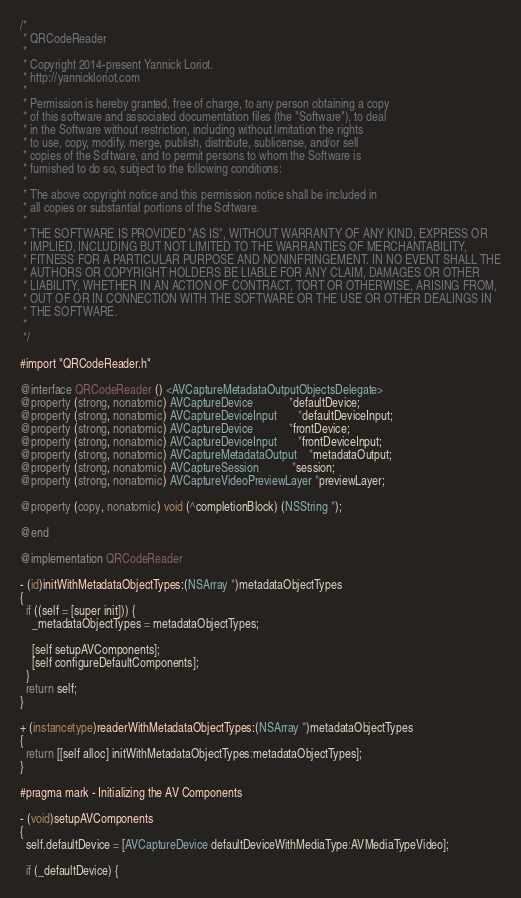<code> <loc_0><loc_0><loc_500><loc_500><_ObjectiveC_>/*
 * QRCodeReader
 *
 * Copyright 2014-present Yannick Loriot.
 * http://yannickloriot.com
 *
 * Permission is hereby granted, free of charge, to any person obtaining a copy
 * of this software and associated documentation files (the "Software"), to deal
 * in the Software without restriction, including without limitation the rights
 * to use, copy, modify, merge, publish, distribute, sublicense, and/or sell
 * copies of the Software, and to permit persons to whom the Software is
 * furnished to do so, subject to the following conditions:
 *
 * The above copyright notice and this permission notice shall be included in
 * all copies or substantial portions of the Software.
 *
 * THE SOFTWARE IS PROVIDED "AS IS", WITHOUT WARRANTY OF ANY KIND, EXPRESS OR
 * IMPLIED, INCLUDING BUT NOT LIMITED TO THE WARRANTIES OF MERCHANTABILITY,
 * FITNESS FOR A PARTICULAR PURPOSE AND NONINFRINGEMENT. IN NO EVENT SHALL THE
 * AUTHORS OR COPYRIGHT HOLDERS BE LIABLE FOR ANY CLAIM, DAMAGES OR OTHER
 * LIABILITY, WHETHER IN AN ACTION OF CONTRACT, TORT OR OTHERWISE, ARISING FROM,
 * OUT OF OR IN CONNECTION WITH THE SOFTWARE OR THE USE OR OTHER DEALINGS IN
 * THE SOFTWARE.
 *
 */

#import "QRCodeReader.h"

@interface QRCodeReader () <AVCaptureMetadataOutputObjectsDelegate>
@property (strong, nonatomic) AVCaptureDevice            *defaultDevice;
@property (strong, nonatomic) AVCaptureDeviceInput       *defaultDeviceInput;
@property (strong, nonatomic) AVCaptureDevice            *frontDevice;
@property (strong, nonatomic) AVCaptureDeviceInput       *frontDeviceInput;
@property (strong, nonatomic) AVCaptureMetadataOutput    *metadataOutput;
@property (strong, nonatomic) AVCaptureSession           *session;
@property (strong, nonatomic) AVCaptureVideoPreviewLayer *previewLayer;

@property (copy, nonatomic) void (^completionBlock) (NSString *);

@end

@implementation QRCodeReader

- (id)initWithMetadataObjectTypes:(NSArray *)metadataObjectTypes
{
  if ((self = [super init])) {
    _metadataObjectTypes = metadataObjectTypes;

    [self setupAVComponents];
    [self configureDefaultComponents];
  }
  return self;
}

+ (instancetype)readerWithMetadataObjectTypes:(NSArray *)metadataObjectTypes
{
  return [[self alloc] initWithMetadataObjectTypes:metadataObjectTypes];
}

#pragma mark - Initializing the AV Components

- (void)setupAVComponents
{
  self.defaultDevice = [AVCaptureDevice defaultDeviceWithMediaType:AVMediaTypeVideo];

  if (_defaultDevice) {</code> 